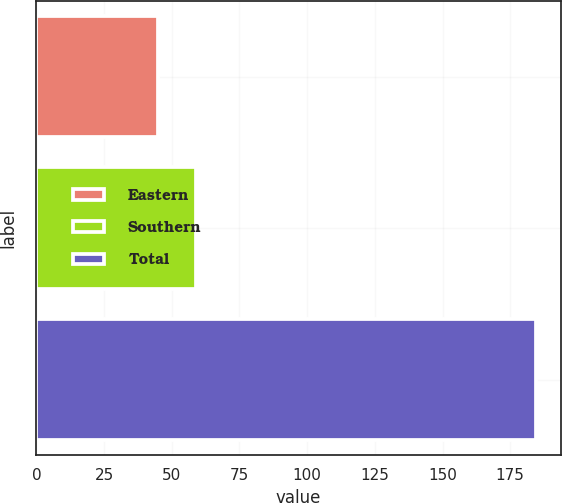Convert chart to OTSL. <chart><loc_0><loc_0><loc_500><loc_500><bar_chart><fcel>Eastern<fcel>Southern<fcel>Total<nl><fcel>45<fcel>58.94<fcel>184.4<nl></chart> 